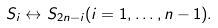<formula> <loc_0><loc_0><loc_500><loc_500>S _ { i } \leftrightarrow S _ { 2 n - i } ( i = 1 , \dots , n - 1 ) .</formula> 